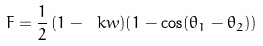Convert formula to latex. <formula><loc_0><loc_0><loc_500><loc_500>F = \frac { 1 } { 2 } \, ( 1 - \ k w ) ( 1 - \cos ( \theta _ { 1 } - \theta _ { 2 } ) )</formula> 